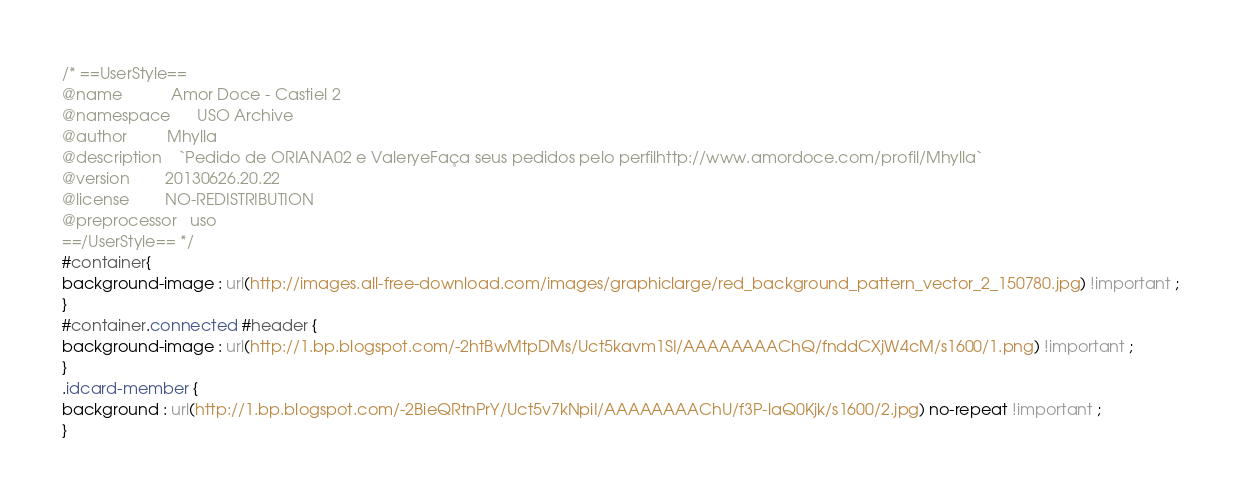<code> <loc_0><loc_0><loc_500><loc_500><_CSS_>/* ==UserStyle==
@name           Amor Doce - Castiel 2
@namespace      USO Archive
@author         Mhylla
@description    `Pedido de ORIANA02 e ValeryeFaça seus pedidos pelo perfilhttp://www.amordoce.com/profil/Mhylla`
@version        20130626.20.22
@license        NO-REDISTRIBUTION
@preprocessor   uso
==/UserStyle== */
#container{
background-image : url(http://images.all-free-download.com/images/graphiclarge/red_background_pattern_vector_2_150780.jpg) !important ;
}
#container.connected #header {
background-image : url(http://1.bp.blogspot.com/-2htBwMtpDMs/Uct5kavm1SI/AAAAAAAAChQ/fnddCXjW4cM/s1600/1.png) !important ;
}
.idcard-member {
background : url(http://1.bp.blogspot.com/-2BieQRtnPrY/Uct5v7kNpiI/AAAAAAAAChU/f3P-laQ0Kjk/s1600/2.jpg) no-repeat !important ;
}</code> 